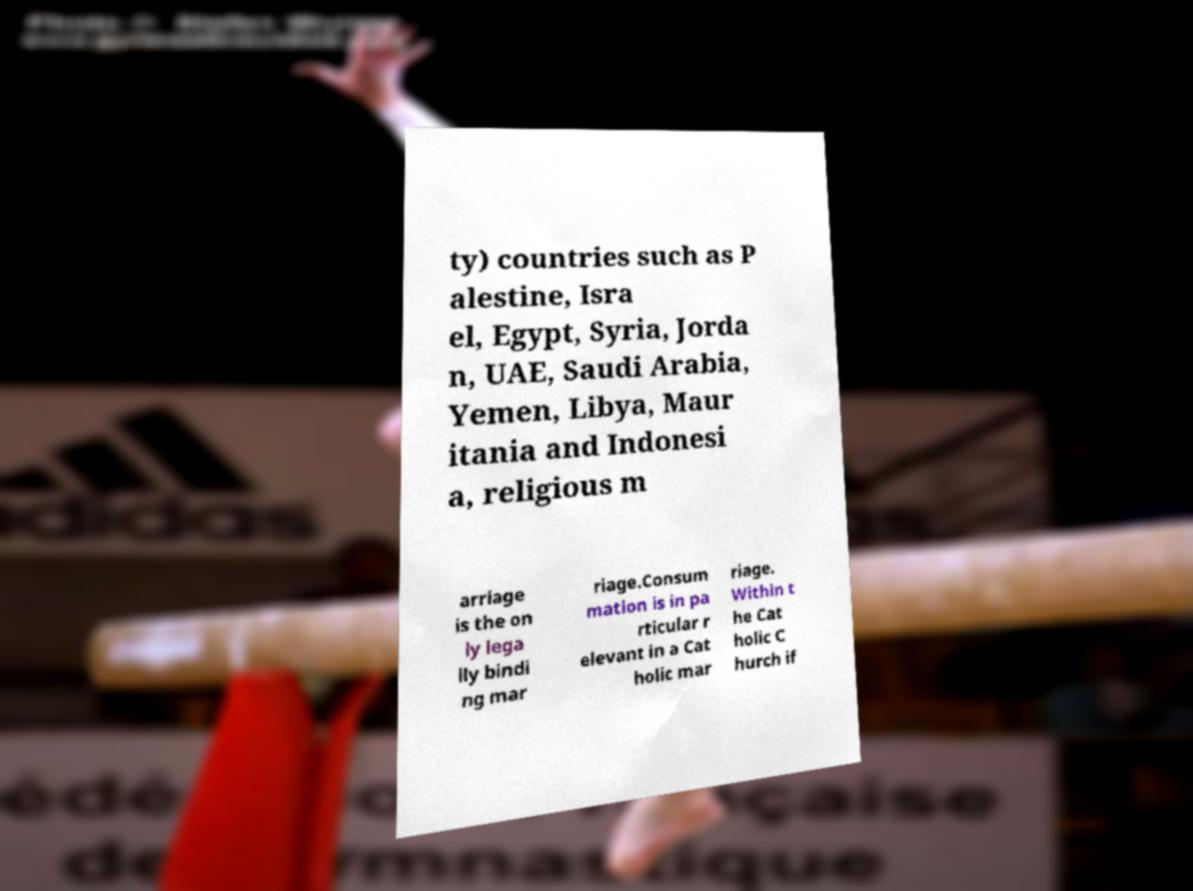What messages or text are displayed in this image? I need them in a readable, typed format. ty) countries such as P alestine, Isra el, Egypt, Syria, Jorda n, UAE, Saudi Arabia, Yemen, Libya, Maur itania and Indonesi a, religious m arriage is the on ly lega lly bindi ng mar riage.Consum mation is in pa rticular r elevant in a Cat holic mar riage. Within t he Cat holic C hurch if 